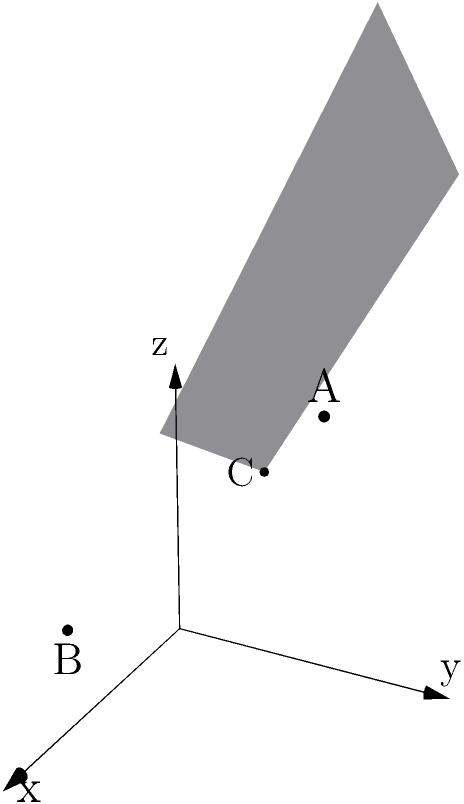In the context of quantum mechanics, consider a three-dimensional Hilbert space representing a quantum system. Three orthogonal states are represented by points A(1,2,3), B(2,0,1), and C(0,1,2) in this space. Determine the equation of the plane passing through these three points, which could represent a subspace of possible quantum states. How might this plane's equation inform our understanding of the system's possible configurations? To find the equation of a plane passing through three points, we can follow these steps:

1) The general equation of a plane is $ax + by + cz + d = 0$, where $(a,b,c)$ is the normal vector to the plane.

2) We can find the normal vector by calculating the cross product of two vectors lying on the plane. Let's choose vectors $\vec{AB}$ and $\vec{AC}$:

   $\vec{AB} = B - A = (2,0,1) - (1,2,3) = (1,-2,-2)$
   $\vec{AC} = C - A = (0,1,2) - (1,2,3) = (-1,-1,-1)$

3) The normal vector $\vec{n} = (a,b,c)$ is the cross product of these vectors:

   $\vec{n} = \vec{AB} \times \vec{AC} = \begin{vmatrix} 
   i & j & k \\
   1 & -2 & -2 \\
   -1 & -1 & -1
   \end{vmatrix} = (0,-1,1)$

4) So, our plane equation is of the form $0x - y + z + d = 0$, or simplified: $z - y + d = 0$

5) To find $d$, we can substitute the coordinates of any of the given points. Let's use A(1,2,3):

   $3 - 2 + d = 0$
   $d = -1$

6) Therefore, the equation of the plane is:

   $z - y - 1 = 0$ or $y + z = 1$

In the context of quantum mechanics, this plane equation represents a subspace of possible quantum states in our three-dimensional Hilbert space. The coefficients in the equation ($0$ for $x$, $1$ for $y$, and $1$ for $z$) indicate how each basis state contributes to the overall quantum state. The constant term ($-1$) represents a phase factor. This equation constrains the possible configurations of the quantum system, suggesting that only states satisfying this linear relationship are accessible within this subspace.
Answer: $y + z = 1$ 